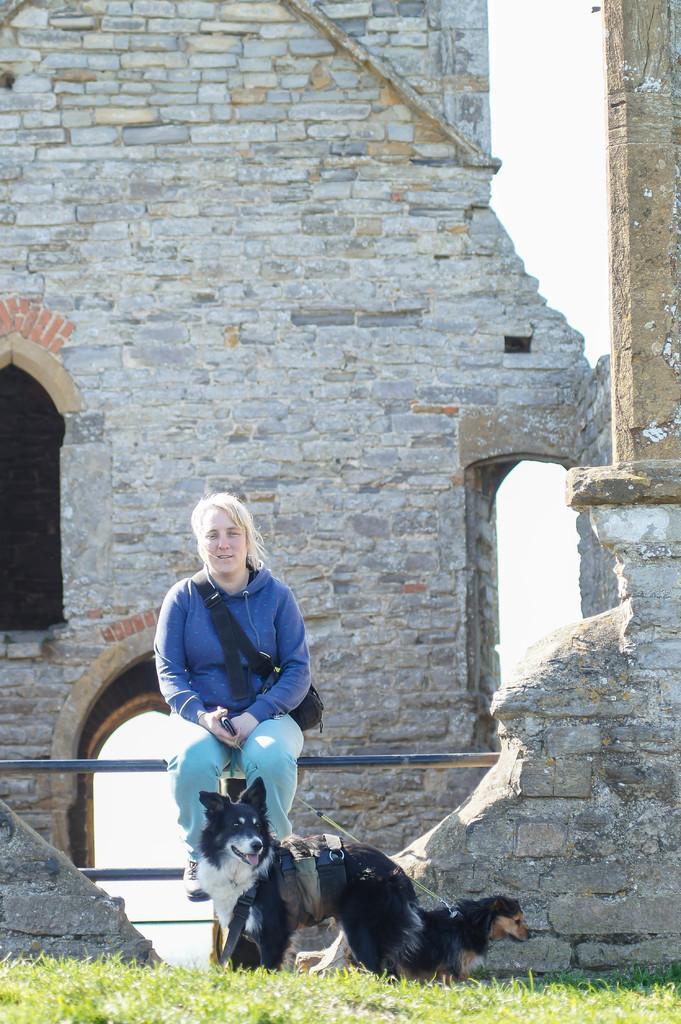In one or two sentences, can you explain what this image depicts? In this image I can see a person sitting on the fencing and wearing blue top and jeans. In front I can see a dogs. They are in brown,black and white color. I can see a building and windows. The sky is in white color. 